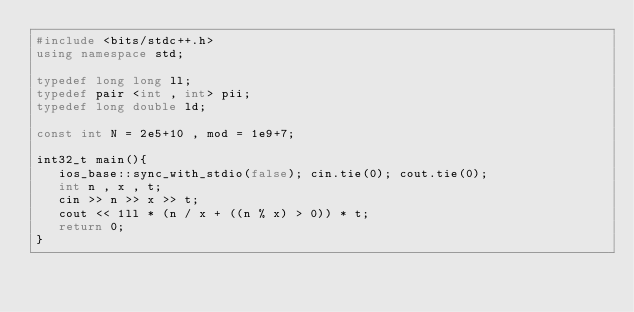Convert code to text. <code><loc_0><loc_0><loc_500><loc_500><_C++_>#include <bits/stdc++.h>
using namespace std;

typedef long long ll;
typedef pair <int , int> pii;
typedef long double ld;

const int N = 2e5+10 , mod = 1e9+7;

int32_t main(){
   ios_base::sync_with_stdio(false); cin.tie(0); cout.tie(0);
   int n , x , t;
   cin >> n >> x >> t;
   cout << 1ll * (n / x + ((n % x) > 0)) * t;
   return 0;
}
</code> 